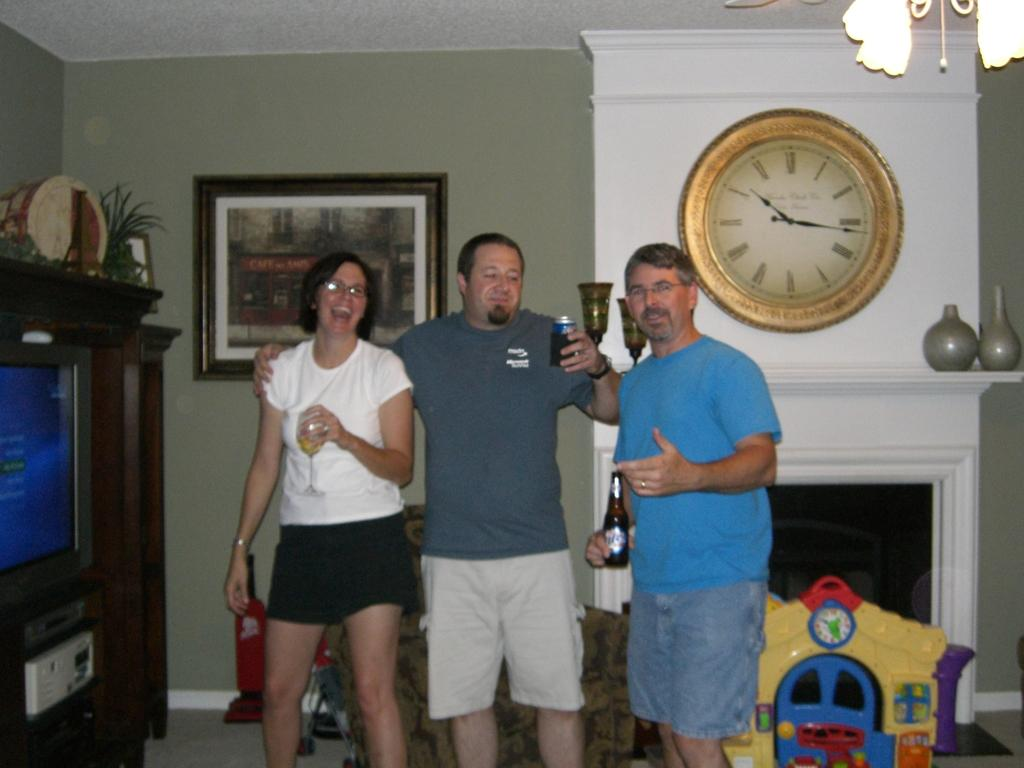<image>
Write a terse but informative summary of the picture. A group of boomers pose near a large wall clock showing 10:16 as the time. 